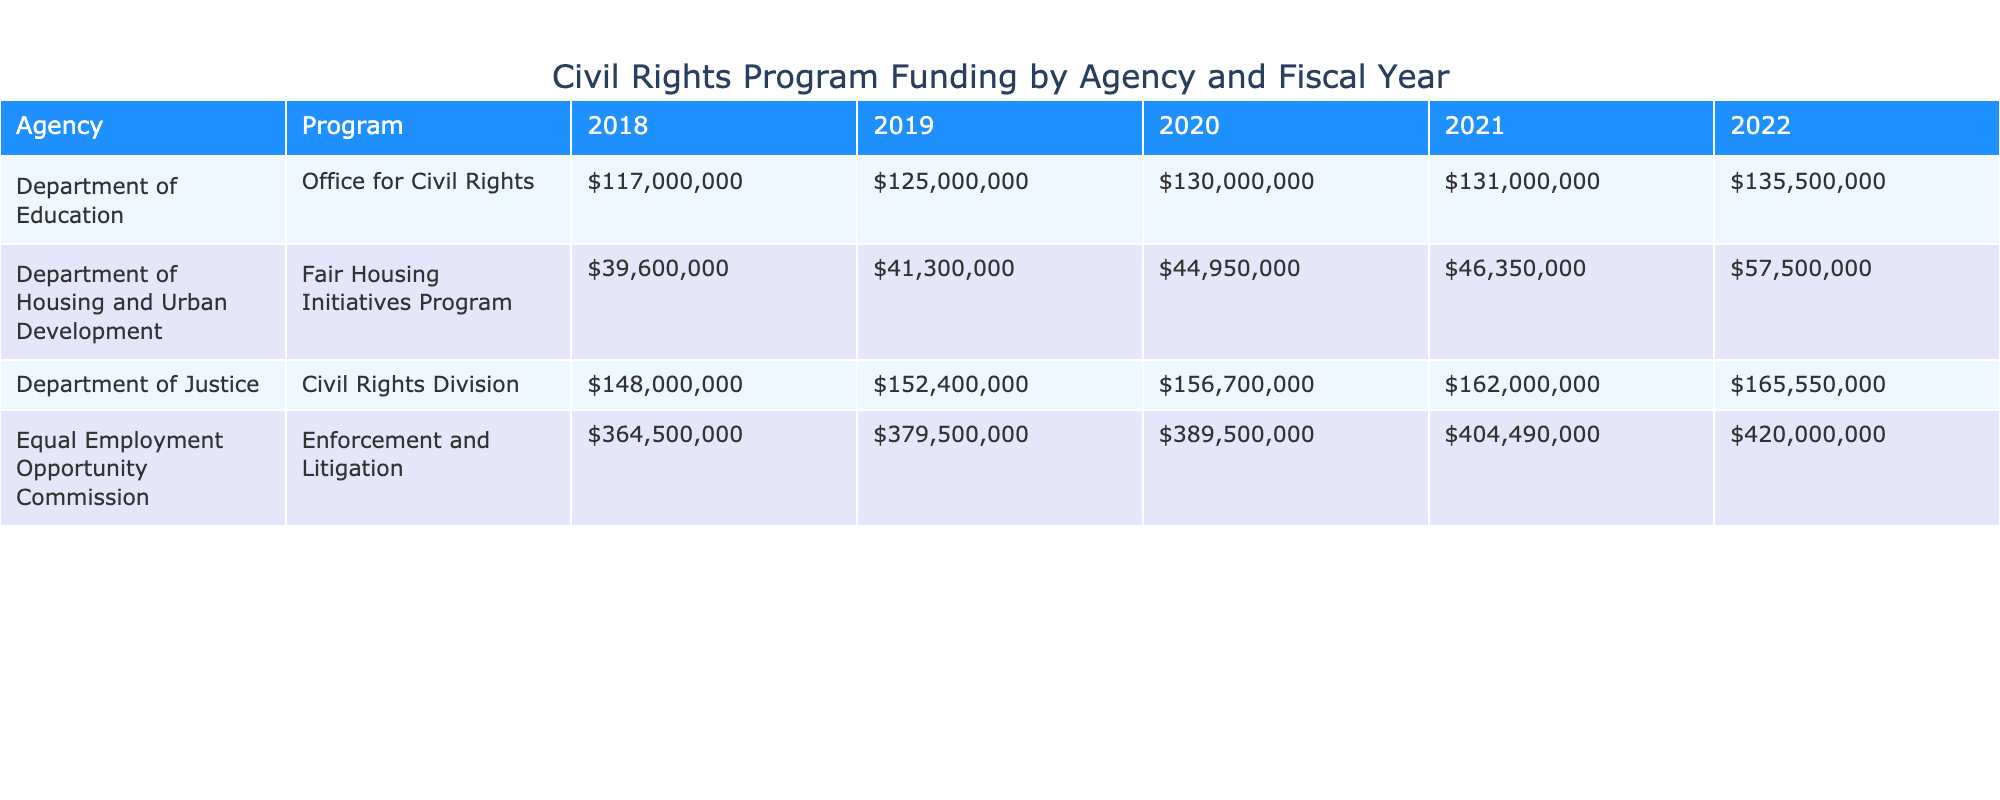What was the total funding amount allocated to the Department of Justice for the Civil Rights Division in 2020? In 2020, the funding amount for the Department of Justice's Civil Rights Division is listed as $156,700,000 in the table.
Answer: $156,700,000 Which agency received the highest funding amount in 2021? To determine the highest funding amount in 2021, we look at each agency's total funding for that fiscal year: Department of Justice received $162,000,000, Department of Education received $131,000,000, Equal Employment Opportunity Commission received $404,490,000, and Department of Housing and Urban Development received $46,350,000. The Equal Employment Opportunity Commission has the highest at $404,490,000.
Answer: Equal Employment Opportunity Commission How much funding did the Office for Civil Rights receive in total from 2018 to 2022? The funding amounts for the Office for Civil Rights over those years are: 2018: $117,000,000, 2019: $125,000,000, 2020: $130,000,000, 2021: $131,000,000, and 2022: $135,500,000. Adding these amounts gives us $117,000,000 + $125,000,000 + $130,000,000 + $131,000,000 + $135,500,000 = $638,500,000.
Answer: $638,500,000 Did the funding for the Fair Housing Initiatives Program increase every year from 2018 to 2022? The funding amounts for the Fair Housing Initiatives Program over these years are: 2018: $39,600,000, 2019: $41,300,000, 2020: $44,950,000, 2021: $46,350,000, and 2022: $57,500,000. We can see that the funds increased each year, confirming that funding did increase every year.
Answer: Yes What is the average funding amount for the Equal Employment Opportunity Commission from 2018 to 2022? The funding amounts for the Equal Employment Opportunity Commission over these years are: 2018: $364,500,000, 2019: $379,500,000, 2020: $389,500,000, 2021: $404,490,000, and 2022: $420,000,000. First, we sum the amounts: $364,500,000 + $379,500,000 + $389,500,000 + $404,490,000 + $420,000,000 = $1,957,990,000. Next, we divide by the number of years (5): $1,957,990,000 / 5 = $391,598,000.
Answer: $391,598,000 